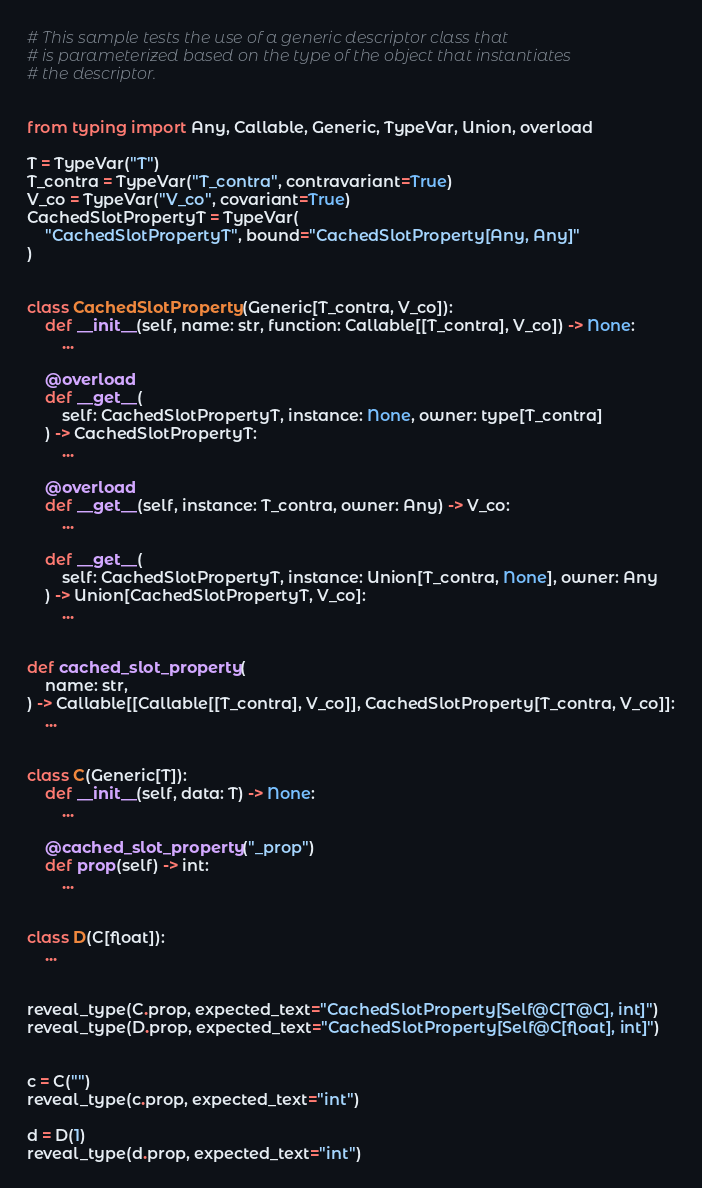<code> <loc_0><loc_0><loc_500><loc_500><_Python_># This sample tests the use of a generic descriptor class that
# is parameterized based on the type of the object that instantiates
# the descriptor.


from typing import Any, Callable, Generic, TypeVar, Union, overload

T = TypeVar("T")
T_contra = TypeVar("T_contra", contravariant=True)
V_co = TypeVar("V_co", covariant=True)
CachedSlotPropertyT = TypeVar(
    "CachedSlotPropertyT", bound="CachedSlotProperty[Any, Any]"
)


class CachedSlotProperty(Generic[T_contra, V_co]):
    def __init__(self, name: str, function: Callable[[T_contra], V_co]) -> None:
        ...

    @overload
    def __get__(
        self: CachedSlotPropertyT, instance: None, owner: type[T_contra]
    ) -> CachedSlotPropertyT:
        ...

    @overload
    def __get__(self, instance: T_contra, owner: Any) -> V_co:
        ...

    def __get__(
        self: CachedSlotPropertyT, instance: Union[T_contra, None], owner: Any
    ) -> Union[CachedSlotPropertyT, V_co]:
        ...


def cached_slot_property(
    name: str,
) -> Callable[[Callable[[T_contra], V_co]], CachedSlotProperty[T_contra, V_co]]:
    ...


class C(Generic[T]):
    def __init__(self, data: T) -> None:
        ...

    @cached_slot_property("_prop")
    def prop(self) -> int:
        ...


class D(C[float]):
    ...


reveal_type(C.prop, expected_text="CachedSlotProperty[Self@C[T@C], int]")
reveal_type(D.prop, expected_text="CachedSlotProperty[Self@C[float], int]")


c = C("")
reveal_type(c.prop, expected_text="int")

d = D(1)
reveal_type(d.prop, expected_text="int")
</code> 